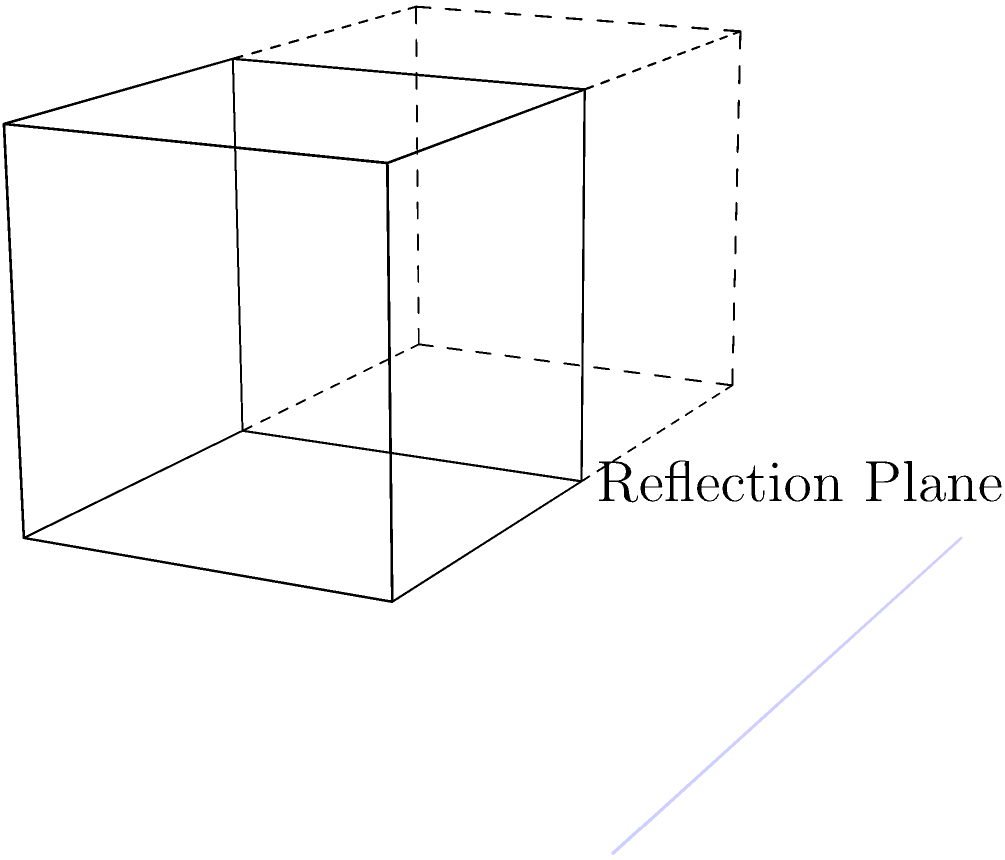In the context of cognitive science and machine-human dialogues, consider the 3D transformation shown in the figure. A unit cube is reflected across the YZ-plane (the blue plane in the image). If the original cube has a vertex at coordinates $(1, 1, 1)$, what are the coordinates of the corresponding vertex in the reflected cube? Explain how this transformation relates to the concept of spatial reasoning in both human cognition and machine learning models. To solve this problem and understand its relevance to cognitive science and machine-human dialogues, let's break it down step-by-step:

1. Reflection across the YZ-plane:
   The YZ-plane is defined by x = 0. Reflection across this plane changes the sign of the x-coordinate while leaving y and z coordinates unchanged.

2. Original vertex coordinates: $(1, 1, 1)$
   
3. Reflection transformation:
   - x-coordinate: $1 \rightarrow -1$ (sign change)
   - y-coordinate: $1 \rightarrow 1$ (unchanged)
   - z-coordinate: $1 \rightarrow 1$ (unchanged)

4. Reflected vertex coordinates: $(-1, 1, 1)$

5. Relevance to cognitive science and machine-human dialogues:
   a) Spatial reasoning: This problem demonstrates spatial reasoning, a key aspect of human cognition. Humans use mental rotation and reflection to solve such problems, which involves visualizing objects in different orientations.
   
   b) Mental models: The ability to construct and manipulate mental models of 3D objects is crucial for both human cognition and advanced AI systems in spatial tasks.
   
   c) Representation learning: In machine learning, especially in computer vision and robotics, learning to represent and transform 3D objects is essential. This problem illustrates a basic geometric transformation that ML models need to learn for tasks involving 3D perception.
   
   d) Abstraction and generalization: The ability to abstract the concept of reflection and apply it to different scenarios is a hallmark of human intelligence that AI systems strive to emulate.
   
   e) Human-machine interaction: In designing interfaces or virtual environments, understanding how humans perceive and reason about 3D transformations is crucial for creating intuitive and user-friendly systems.

By studying how humans solve such spatial problems, researchers can gain insights into cognitive processes and potentially improve machine learning models for 3D reasoning tasks, enhancing machine-human dialogues in spatial domains.
Answer: $(-1, 1, 1)$ 